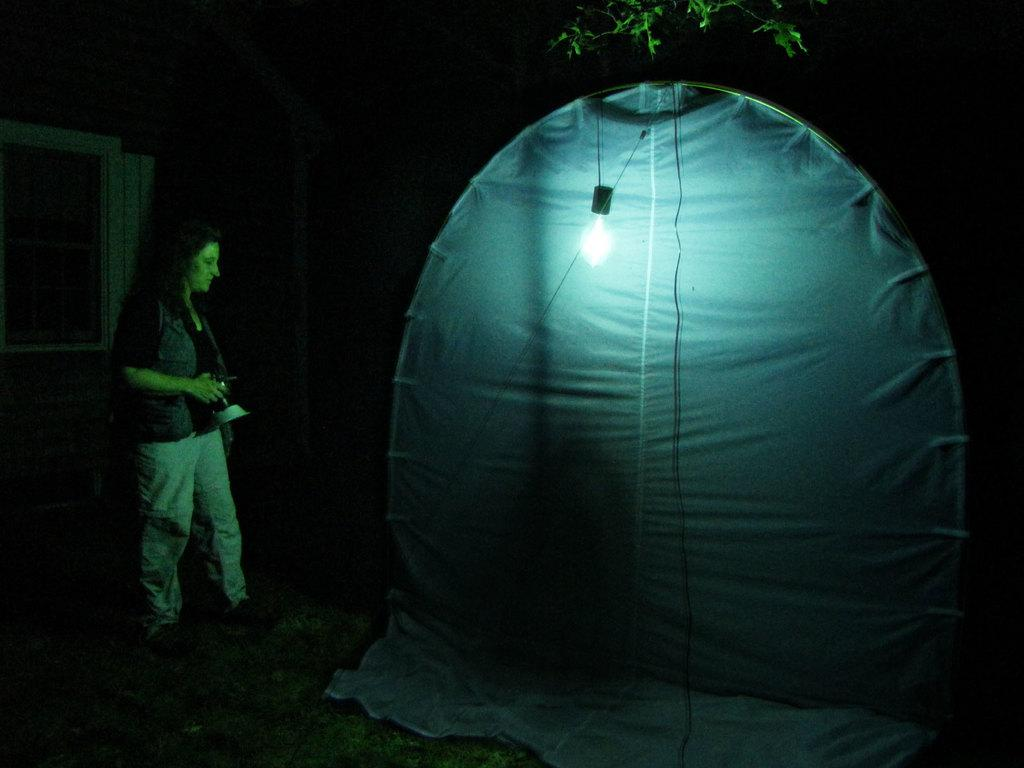What is the main subject of the image? There is a woman standing in the image. What is the woman holding in her hands? The woman is holding an object in her hands. What structure is visible in front of the woman? There is a tent in front of the woman. Can you describe the interior of the tent? There is a light inside the tent. Are there any fairies visible inside the tent? There are no fairies present in the image, as it only features a woman, an object, a tent, and a light. What date is marked on the calendar in the image? There is no calendar present in the image, so it is not possible to determine the date. 